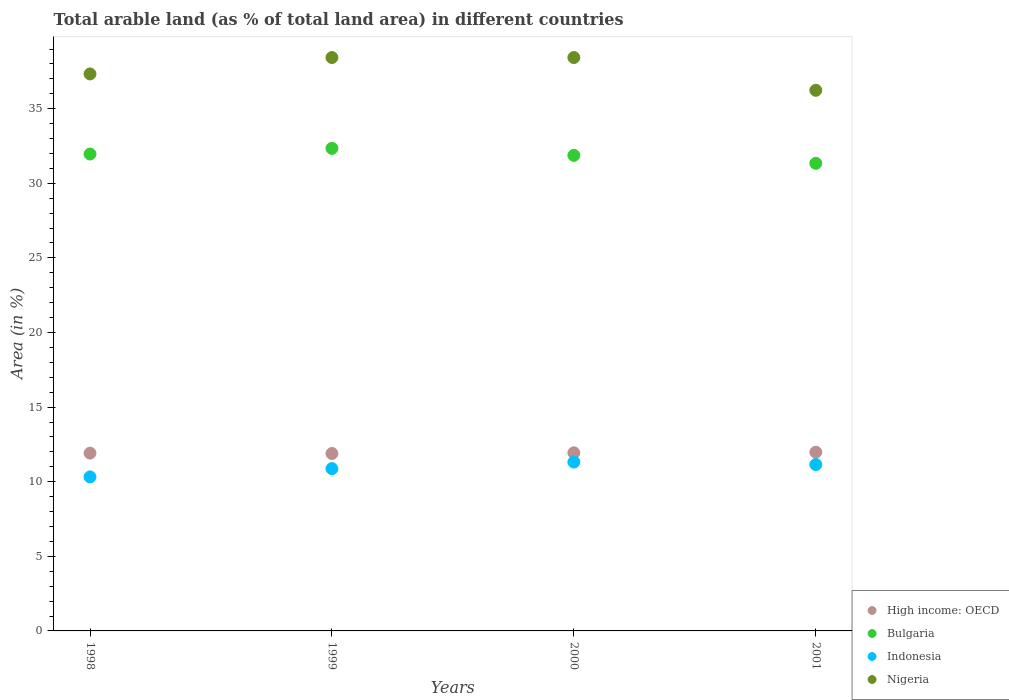What is the percentage of arable land in Indonesia in 2001?
Provide a succinct answer. 11.15. Across all years, what is the maximum percentage of arable land in Nigeria?
Your answer should be compact. 38.43. Across all years, what is the minimum percentage of arable land in Bulgaria?
Provide a short and direct response. 31.34. In which year was the percentage of arable land in Bulgaria minimum?
Keep it short and to the point. 2001. What is the total percentage of arable land in Bulgaria in the graph?
Your response must be concise. 127.52. What is the difference between the percentage of arable land in High income: OECD in 1999 and that in 2000?
Make the answer very short. -0.05. What is the difference between the percentage of arable land in High income: OECD in 1998 and the percentage of arable land in Nigeria in 2001?
Offer a terse response. -24.32. What is the average percentage of arable land in Nigeria per year?
Provide a short and direct response. 37.61. In the year 2000, what is the difference between the percentage of arable land in High income: OECD and percentage of arable land in Bulgaria?
Give a very brief answer. -19.93. In how many years, is the percentage of arable land in Nigeria greater than 7 %?
Give a very brief answer. 4. What is the ratio of the percentage of arable land in Indonesia in 1999 to that in 2000?
Make the answer very short. 0.96. Is the percentage of arable land in Indonesia in 1999 less than that in 2000?
Give a very brief answer. Yes. What is the difference between the highest and the second highest percentage of arable land in Bulgaria?
Your response must be concise. 0.38. What is the difference between the highest and the lowest percentage of arable land in Bulgaria?
Provide a succinct answer. 1. Is the sum of the percentage of arable land in High income: OECD in 1998 and 1999 greater than the maximum percentage of arable land in Indonesia across all years?
Provide a short and direct response. Yes. Does the percentage of arable land in Indonesia monotonically increase over the years?
Make the answer very short. No. What is the difference between two consecutive major ticks on the Y-axis?
Give a very brief answer. 5. Does the graph contain any zero values?
Your answer should be very brief. No. How are the legend labels stacked?
Keep it short and to the point. Vertical. What is the title of the graph?
Your answer should be compact. Total arable land (as % of total land area) in different countries. What is the label or title of the X-axis?
Your response must be concise. Years. What is the label or title of the Y-axis?
Provide a succinct answer. Area (in %). What is the Area (in %) in High income: OECD in 1998?
Give a very brief answer. 11.92. What is the Area (in %) of Bulgaria in 1998?
Offer a terse response. 31.96. What is the Area (in %) of Indonesia in 1998?
Give a very brief answer. 10.32. What is the Area (in %) of Nigeria in 1998?
Give a very brief answer. 37.33. What is the Area (in %) in High income: OECD in 1999?
Your answer should be very brief. 11.89. What is the Area (in %) in Bulgaria in 1999?
Keep it short and to the point. 32.34. What is the Area (in %) in Indonesia in 1999?
Your answer should be compact. 10.87. What is the Area (in %) of Nigeria in 1999?
Provide a succinct answer. 38.43. What is the Area (in %) of High income: OECD in 2000?
Ensure brevity in your answer.  11.94. What is the Area (in %) in Bulgaria in 2000?
Keep it short and to the point. 31.87. What is the Area (in %) in Indonesia in 2000?
Your answer should be very brief. 11.32. What is the Area (in %) of Nigeria in 2000?
Offer a very short reply. 38.43. What is the Area (in %) in High income: OECD in 2001?
Provide a succinct answer. 11.98. What is the Area (in %) in Bulgaria in 2001?
Offer a terse response. 31.34. What is the Area (in %) in Indonesia in 2001?
Give a very brief answer. 11.15. What is the Area (in %) in Nigeria in 2001?
Ensure brevity in your answer.  36.23. Across all years, what is the maximum Area (in %) in High income: OECD?
Ensure brevity in your answer.  11.98. Across all years, what is the maximum Area (in %) of Bulgaria?
Keep it short and to the point. 32.34. Across all years, what is the maximum Area (in %) of Indonesia?
Ensure brevity in your answer.  11.32. Across all years, what is the maximum Area (in %) of Nigeria?
Provide a short and direct response. 38.43. Across all years, what is the minimum Area (in %) of High income: OECD?
Provide a succinct answer. 11.89. Across all years, what is the minimum Area (in %) of Bulgaria?
Give a very brief answer. 31.34. Across all years, what is the minimum Area (in %) of Indonesia?
Provide a short and direct response. 10.32. Across all years, what is the minimum Area (in %) in Nigeria?
Your answer should be very brief. 36.23. What is the total Area (in %) of High income: OECD in the graph?
Your response must be concise. 47.72. What is the total Area (in %) in Bulgaria in the graph?
Provide a short and direct response. 127.52. What is the total Area (in %) of Indonesia in the graph?
Provide a short and direct response. 43.66. What is the total Area (in %) in Nigeria in the graph?
Ensure brevity in your answer.  150.42. What is the difference between the Area (in %) in High income: OECD in 1998 and that in 1999?
Give a very brief answer. 0.03. What is the difference between the Area (in %) of Bulgaria in 1998 and that in 1999?
Your response must be concise. -0.38. What is the difference between the Area (in %) of Indonesia in 1998 and that in 1999?
Keep it short and to the point. -0.55. What is the difference between the Area (in %) in Nigeria in 1998 and that in 1999?
Your answer should be very brief. -1.1. What is the difference between the Area (in %) of High income: OECD in 1998 and that in 2000?
Keep it short and to the point. -0.02. What is the difference between the Area (in %) of Bulgaria in 1998 and that in 2000?
Your answer should be very brief. 0.09. What is the difference between the Area (in %) of Indonesia in 1998 and that in 2000?
Your response must be concise. -0.99. What is the difference between the Area (in %) in Nigeria in 1998 and that in 2000?
Your answer should be compact. -1.1. What is the difference between the Area (in %) of High income: OECD in 1998 and that in 2001?
Make the answer very short. -0.06. What is the difference between the Area (in %) of Bulgaria in 1998 and that in 2001?
Your answer should be compact. 0.62. What is the difference between the Area (in %) in Indonesia in 1998 and that in 2001?
Your response must be concise. -0.83. What is the difference between the Area (in %) in Nigeria in 1998 and that in 2001?
Your answer should be very brief. 1.1. What is the difference between the Area (in %) in High income: OECD in 1999 and that in 2000?
Your response must be concise. -0.05. What is the difference between the Area (in %) of Bulgaria in 1999 and that in 2000?
Your answer should be compact. 0.47. What is the difference between the Area (in %) of Indonesia in 1999 and that in 2000?
Offer a very short reply. -0.44. What is the difference between the Area (in %) in High income: OECD in 1999 and that in 2001?
Give a very brief answer. -0.09. What is the difference between the Area (in %) in Indonesia in 1999 and that in 2001?
Ensure brevity in your answer.  -0.28. What is the difference between the Area (in %) in Nigeria in 1999 and that in 2001?
Your answer should be very brief. 2.2. What is the difference between the Area (in %) of High income: OECD in 2000 and that in 2001?
Give a very brief answer. -0.04. What is the difference between the Area (in %) of Bulgaria in 2000 and that in 2001?
Provide a succinct answer. 0.53. What is the difference between the Area (in %) of Indonesia in 2000 and that in 2001?
Provide a short and direct response. 0.17. What is the difference between the Area (in %) in Nigeria in 2000 and that in 2001?
Ensure brevity in your answer.  2.2. What is the difference between the Area (in %) in High income: OECD in 1998 and the Area (in %) in Bulgaria in 1999?
Provide a succinct answer. -20.43. What is the difference between the Area (in %) of High income: OECD in 1998 and the Area (in %) of Indonesia in 1999?
Offer a terse response. 1.04. What is the difference between the Area (in %) in High income: OECD in 1998 and the Area (in %) in Nigeria in 1999?
Your answer should be compact. -26.51. What is the difference between the Area (in %) of Bulgaria in 1998 and the Area (in %) of Indonesia in 1999?
Provide a succinct answer. 21.09. What is the difference between the Area (in %) of Bulgaria in 1998 and the Area (in %) of Nigeria in 1999?
Offer a very short reply. -6.47. What is the difference between the Area (in %) in Indonesia in 1998 and the Area (in %) in Nigeria in 1999?
Provide a succinct answer. -28.11. What is the difference between the Area (in %) in High income: OECD in 1998 and the Area (in %) in Bulgaria in 2000?
Give a very brief answer. -19.96. What is the difference between the Area (in %) in High income: OECD in 1998 and the Area (in %) in Indonesia in 2000?
Give a very brief answer. 0.6. What is the difference between the Area (in %) of High income: OECD in 1998 and the Area (in %) of Nigeria in 2000?
Your answer should be compact. -26.51. What is the difference between the Area (in %) in Bulgaria in 1998 and the Area (in %) in Indonesia in 2000?
Keep it short and to the point. 20.65. What is the difference between the Area (in %) of Bulgaria in 1998 and the Area (in %) of Nigeria in 2000?
Your answer should be very brief. -6.47. What is the difference between the Area (in %) of Indonesia in 1998 and the Area (in %) of Nigeria in 2000?
Make the answer very short. -28.11. What is the difference between the Area (in %) of High income: OECD in 1998 and the Area (in %) of Bulgaria in 2001?
Your answer should be compact. -19.42. What is the difference between the Area (in %) of High income: OECD in 1998 and the Area (in %) of Indonesia in 2001?
Your answer should be very brief. 0.77. What is the difference between the Area (in %) in High income: OECD in 1998 and the Area (in %) in Nigeria in 2001?
Your answer should be compact. -24.32. What is the difference between the Area (in %) of Bulgaria in 1998 and the Area (in %) of Indonesia in 2001?
Offer a very short reply. 20.81. What is the difference between the Area (in %) of Bulgaria in 1998 and the Area (in %) of Nigeria in 2001?
Make the answer very short. -4.27. What is the difference between the Area (in %) in Indonesia in 1998 and the Area (in %) in Nigeria in 2001?
Ensure brevity in your answer.  -25.91. What is the difference between the Area (in %) in High income: OECD in 1999 and the Area (in %) in Bulgaria in 2000?
Offer a terse response. -19.98. What is the difference between the Area (in %) in High income: OECD in 1999 and the Area (in %) in Indonesia in 2000?
Your answer should be compact. 0.57. What is the difference between the Area (in %) of High income: OECD in 1999 and the Area (in %) of Nigeria in 2000?
Your answer should be compact. -26.54. What is the difference between the Area (in %) of Bulgaria in 1999 and the Area (in %) of Indonesia in 2000?
Your answer should be compact. 21.03. What is the difference between the Area (in %) of Bulgaria in 1999 and the Area (in %) of Nigeria in 2000?
Your answer should be compact. -6.09. What is the difference between the Area (in %) in Indonesia in 1999 and the Area (in %) in Nigeria in 2000?
Your response must be concise. -27.55. What is the difference between the Area (in %) of High income: OECD in 1999 and the Area (in %) of Bulgaria in 2001?
Your answer should be compact. -19.45. What is the difference between the Area (in %) of High income: OECD in 1999 and the Area (in %) of Indonesia in 2001?
Provide a short and direct response. 0.74. What is the difference between the Area (in %) in High income: OECD in 1999 and the Area (in %) in Nigeria in 2001?
Offer a very short reply. -24.34. What is the difference between the Area (in %) in Bulgaria in 1999 and the Area (in %) in Indonesia in 2001?
Give a very brief answer. 21.19. What is the difference between the Area (in %) in Bulgaria in 1999 and the Area (in %) in Nigeria in 2001?
Ensure brevity in your answer.  -3.89. What is the difference between the Area (in %) of Indonesia in 1999 and the Area (in %) of Nigeria in 2001?
Keep it short and to the point. -25.36. What is the difference between the Area (in %) in High income: OECD in 2000 and the Area (in %) in Bulgaria in 2001?
Offer a terse response. -19.4. What is the difference between the Area (in %) of High income: OECD in 2000 and the Area (in %) of Indonesia in 2001?
Offer a very short reply. 0.79. What is the difference between the Area (in %) in High income: OECD in 2000 and the Area (in %) in Nigeria in 2001?
Keep it short and to the point. -24.29. What is the difference between the Area (in %) in Bulgaria in 2000 and the Area (in %) in Indonesia in 2001?
Give a very brief answer. 20.72. What is the difference between the Area (in %) in Bulgaria in 2000 and the Area (in %) in Nigeria in 2001?
Give a very brief answer. -4.36. What is the difference between the Area (in %) in Indonesia in 2000 and the Area (in %) in Nigeria in 2001?
Give a very brief answer. -24.92. What is the average Area (in %) of High income: OECD per year?
Offer a very short reply. 11.93. What is the average Area (in %) of Bulgaria per year?
Offer a terse response. 31.88. What is the average Area (in %) of Indonesia per year?
Your answer should be compact. 10.92. What is the average Area (in %) of Nigeria per year?
Make the answer very short. 37.61. In the year 1998, what is the difference between the Area (in %) of High income: OECD and Area (in %) of Bulgaria?
Offer a terse response. -20.05. In the year 1998, what is the difference between the Area (in %) in High income: OECD and Area (in %) in Indonesia?
Make the answer very short. 1.59. In the year 1998, what is the difference between the Area (in %) of High income: OECD and Area (in %) of Nigeria?
Your answer should be compact. -25.41. In the year 1998, what is the difference between the Area (in %) in Bulgaria and Area (in %) in Indonesia?
Offer a very short reply. 21.64. In the year 1998, what is the difference between the Area (in %) of Bulgaria and Area (in %) of Nigeria?
Make the answer very short. -5.37. In the year 1998, what is the difference between the Area (in %) in Indonesia and Area (in %) in Nigeria?
Your answer should be very brief. -27.01. In the year 1999, what is the difference between the Area (in %) in High income: OECD and Area (in %) in Bulgaria?
Give a very brief answer. -20.45. In the year 1999, what is the difference between the Area (in %) of High income: OECD and Area (in %) of Indonesia?
Ensure brevity in your answer.  1.01. In the year 1999, what is the difference between the Area (in %) in High income: OECD and Area (in %) in Nigeria?
Give a very brief answer. -26.54. In the year 1999, what is the difference between the Area (in %) of Bulgaria and Area (in %) of Indonesia?
Your answer should be compact. 21.47. In the year 1999, what is the difference between the Area (in %) of Bulgaria and Area (in %) of Nigeria?
Make the answer very short. -6.09. In the year 1999, what is the difference between the Area (in %) of Indonesia and Area (in %) of Nigeria?
Offer a very short reply. -27.55. In the year 2000, what is the difference between the Area (in %) in High income: OECD and Area (in %) in Bulgaria?
Keep it short and to the point. -19.93. In the year 2000, what is the difference between the Area (in %) of High income: OECD and Area (in %) of Indonesia?
Offer a very short reply. 0.62. In the year 2000, what is the difference between the Area (in %) of High income: OECD and Area (in %) of Nigeria?
Keep it short and to the point. -26.49. In the year 2000, what is the difference between the Area (in %) in Bulgaria and Area (in %) in Indonesia?
Offer a very short reply. 20.56. In the year 2000, what is the difference between the Area (in %) of Bulgaria and Area (in %) of Nigeria?
Keep it short and to the point. -6.56. In the year 2000, what is the difference between the Area (in %) in Indonesia and Area (in %) in Nigeria?
Provide a succinct answer. -27.11. In the year 2001, what is the difference between the Area (in %) in High income: OECD and Area (in %) in Bulgaria?
Keep it short and to the point. -19.36. In the year 2001, what is the difference between the Area (in %) in High income: OECD and Area (in %) in Indonesia?
Give a very brief answer. 0.83. In the year 2001, what is the difference between the Area (in %) of High income: OECD and Area (in %) of Nigeria?
Keep it short and to the point. -24.25. In the year 2001, what is the difference between the Area (in %) in Bulgaria and Area (in %) in Indonesia?
Your response must be concise. 20.19. In the year 2001, what is the difference between the Area (in %) of Bulgaria and Area (in %) of Nigeria?
Keep it short and to the point. -4.89. In the year 2001, what is the difference between the Area (in %) of Indonesia and Area (in %) of Nigeria?
Offer a terse response. -25.08. What is the ratio of the Area (in %) in Bulgaria in 1998 to that in 1999?
Your response must be concise. 0.99. What is the ratio of the Area (in %) of Indonesia in 1998 to that in 1999?
Ensure brevity in your answer.  0.95. What is the ratio of the Area (in %) in Nigeria in 1998 to that in 1999?
Offer a very short reply. 0.97. What is the ratio of the Area (in %) of Indonesia in 1998 to that in 2000?
Ensure brevity in your answer.  0.91. What is the ratio of the Area (in %) in Nigeria in 1998 to that in 2000?
Your response must be concise. 0.97. What is the ratio of the Area (in %) of High income: OECD in 1998 to that in 2001?
Keep it short and to the point. 0.99. What is the ratio of the Area (in %) of Bulgaria in 1998 to that in 2001?
Ensure brevity in your answer.  1.02. What is the ratio of the Area (in %) in Indonesia in 1998 to that in 2001?
Give a very brief answer. 0.93. What is the ratio of the Area (in %) of Nigeria in 1998 to that in 2001?
Offer a terse response. 1.03. What is the ratio of the Area (in %) in High income: OECD in 1999 to that in 2000?
Ensure brevity in your answer.  1. What is the ratio of the Area (in %) of Bulgaria in 1999 to that in 2000?
Keep it short and to the point. 1.01. What is the ratio of the Area (in %) of Indonesia in 1999 to that in 2000?
Offer a very short reply. 0.96. What is the ratio of the Area (in %) of Nigeria in 1999 to that in 2000?
Offer a terse response. 1. What is the ratio of the Area (in %) of Bulgaria in 1999 to that in 2001?
Offer a terse response. 1.03. What is the ratio of the Area (in %) in Indonesia in 1999 to that in 2001?
Offer a very short reply. 0.98. What is the ratio of the Area (in %) in Nigeria in 1999 to that in 2001?
Give a very brief answer. 1.06. What is the ratio of the Area (in %) in Bulgaria in 2000 to that in 2001?
Provide a short and direct response. 1.02. What is the ratio of the Area (in %) of Indonesia in 2000 to that in 2001?
Provide a short and direct response. 1.01. What is the ratio of the Area (in %) in Nigeria in 2000 to that in 2001?
Your answer should be very brief. 1.06. What is the difference between the highest and the second highest Area (in %) of High income: OECD?
Provide a short and direct response. 0.04. What is the difference between the highest and the second highest Area (in %) in Bulgaria?
Offer a terse response. 0.38. What is the difference between the highest and the second highest Area (in %) of Indonesia?
Ensure brevity in your answer.  0.17. What is the difference between the highest and the lowest Area (in %) in High income: OECD?
Make the answer very short. 0.09. What is the difference between the highest and the lowest Area (in %) in Nigeria?
Offer a terse response. 2.2. 